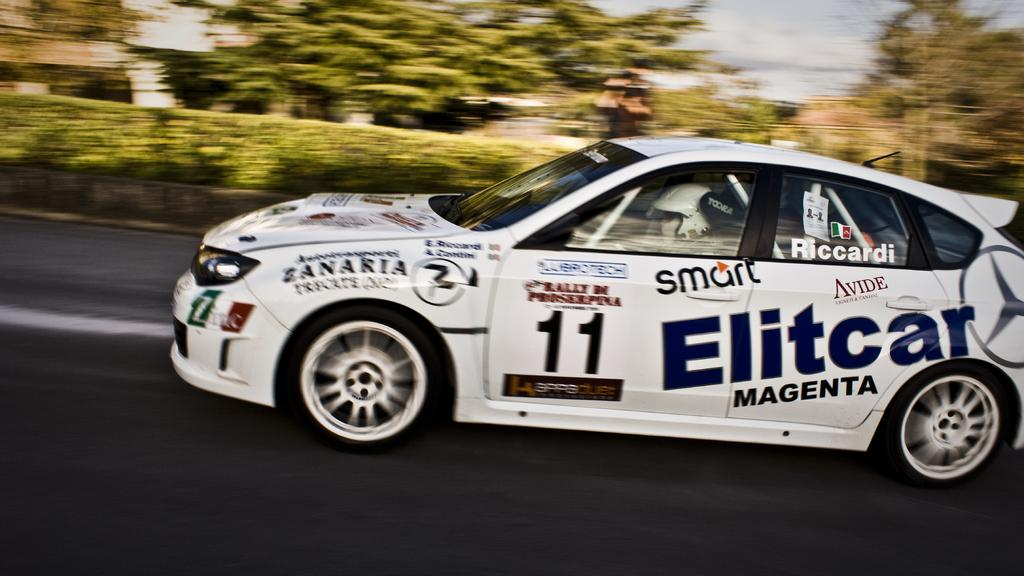What is the main subject of the image? There is a car on the road in the image. What can be seen in the background of the image? There are trees and bushes in the background of the image. Is there anyone inside the car? Yes, there is a person sitting inside the car. What type of beef is being advertised on the side of the car? There is no beef or advertisement present on the side of the car in the image. 